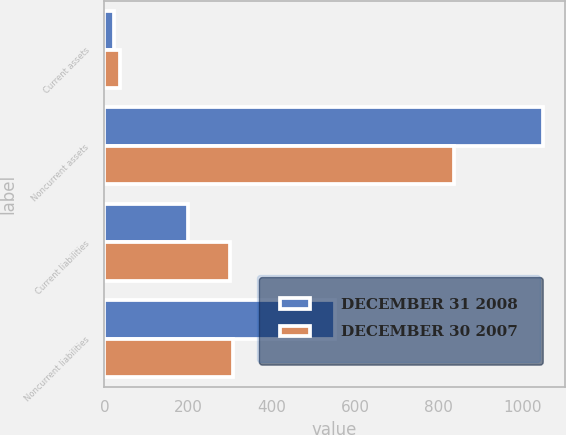Convert chart to OTSL. <chart><loc_0><loc_0><loc_500><loc_500><stacked_bar_chart><ecel><fcel>Current assets<fcel>Noncurrent assets<fcel>Current liabilities<fcel>Noncurrent liabilities<nl><fcel>DECEMBER 31 2008<fcel>24<fcel>1050<fcel>199<fcel>552<nl><fcel>DECEMBER 30 2007<fcel>38<fcel>836<fcel>301<fcel>307<nl></chart> 